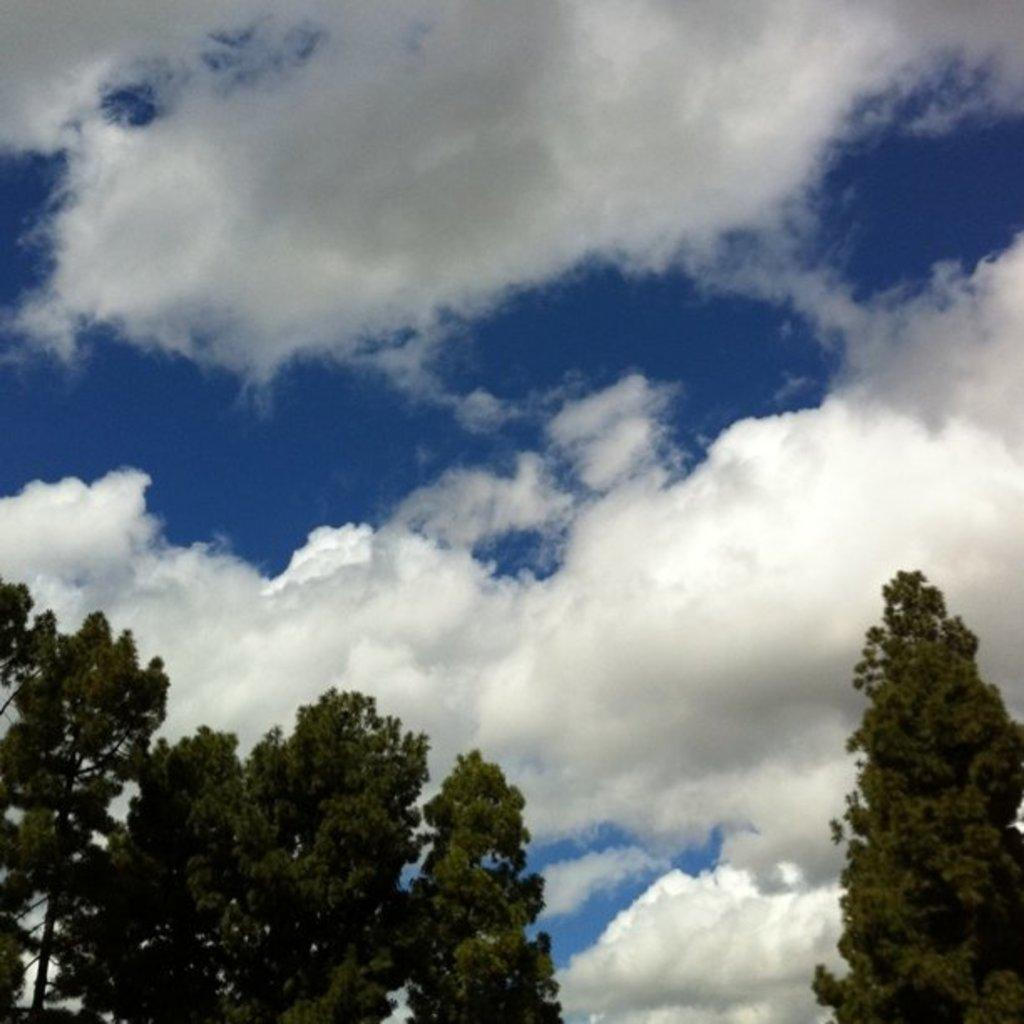What type of vegetation can be seen in the image? There are trees in the image. What part of the natural environment is visible in the image? The sky is visible in the image. How would you describe the sky in the image? The sky appears to be cloudy. What type of creature can be seen wearing a vest and holding a note in the image? There is no creature, vest, or note present in the image; it only features trees and a cloudy sky. 